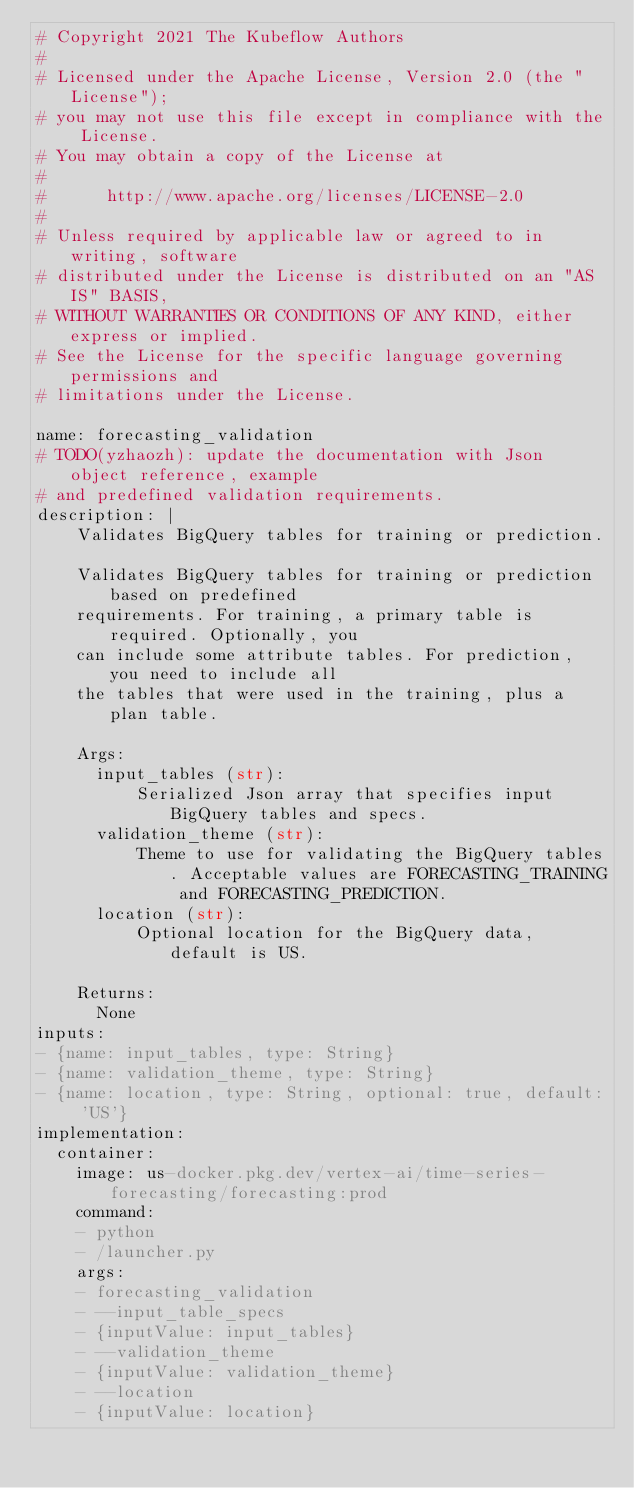<code> <loc_0><loc_0><loc_500><loc_500><_YAML_># Copyright 2021 The Kubeflow Authors
#
# Licensed under the Apache License, Version 2.0 (the "License");
# you may not use this file except in compliance with the License.
# You may obtain a copy of the License at
#
#      http://www.apache.org/licenses/LICENSE-2.0
#
# Unless required by applicable law or agreed to in writing, software
# distributed under the License is distributed on an "AS IS" BASIS,
# WITHOUT WARRANTIES OR CONDITIONS OF ANY KIND, either express or implied.
# See the License for the specific language governing permissions and
# limitations under the License.

name: forecasting_validation
# TODO(yzhaozh): update the documentation with Json object reference, example
# and predefined validation requirements.
description: |
    Validates BigQuery tables for training or prediction.

    Validates BigQuery tables for training or prediction based on predefined
    requirements. For training, a primary table is required. Optionally, you
    can include some attribute tables. For prediction, you need to include all
    the tables that were used in the training, plus a plan table.

    Args:
      input_tables (str):
          Serialized Json array that specifies input BigQuery tables and specs.
      validation_theme (str):
          Theme to use for validating the BigQuery tables. Acceptable values are FORECASTING_TRAINING and FORECASTING_PREDICTION.
      location (str):
          Optional location for the BigQuery data, default is US.

    Returns:
      None
inputs:
- {name: input_tables, type: String}
- {name: validation_theme, type: String}
- {name: location, type: String, optional: true, default: 'US'}
implementation:
  container:
    image: us-docker.pkg.dev/vertex-ai/time-series-forecasting/forecasting:prod
    command:
    - python
    - /launcher.py
    args:
    - forecasting_validation
    - --input_table_specs
    - {inputValue: input_tables}
    - --validation_theme
    - {inputValue: validation_theme}
    - --location
    - {inputValue: location}
</code> 